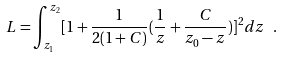Convert formula to latex. <formula><loc_0><loc_0><loc_500><loc_500>L = \int _ { z _ { 1 } } ^ { z _ { 2 } } [ 1 + \frac { 1 } { 2 ( 1 + C ) } ( \frac { 1 } { z } + \frac { C } { z _ { 0 } - z } ) ] ^ { 2 } d z \ .</formula> 